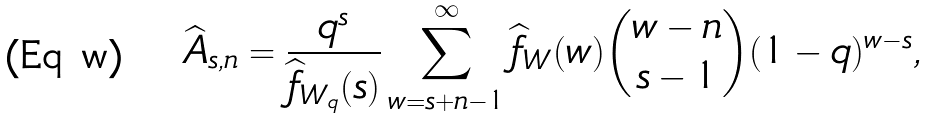<formula> <loc_0><loc_0><loc_500><loc_500>\widehat { A } _ { s , n } = \frac { q ^ { s } } { \widehat { f } _ { W _ { q } } ( s ) } \sum _ { w = s + n - 1 } ^ { \infty } \widehat { f } _ { W } ( w ) { w - n \choose s - 1 } ( 1 - q ) ^ { w - s } ,</formula> 